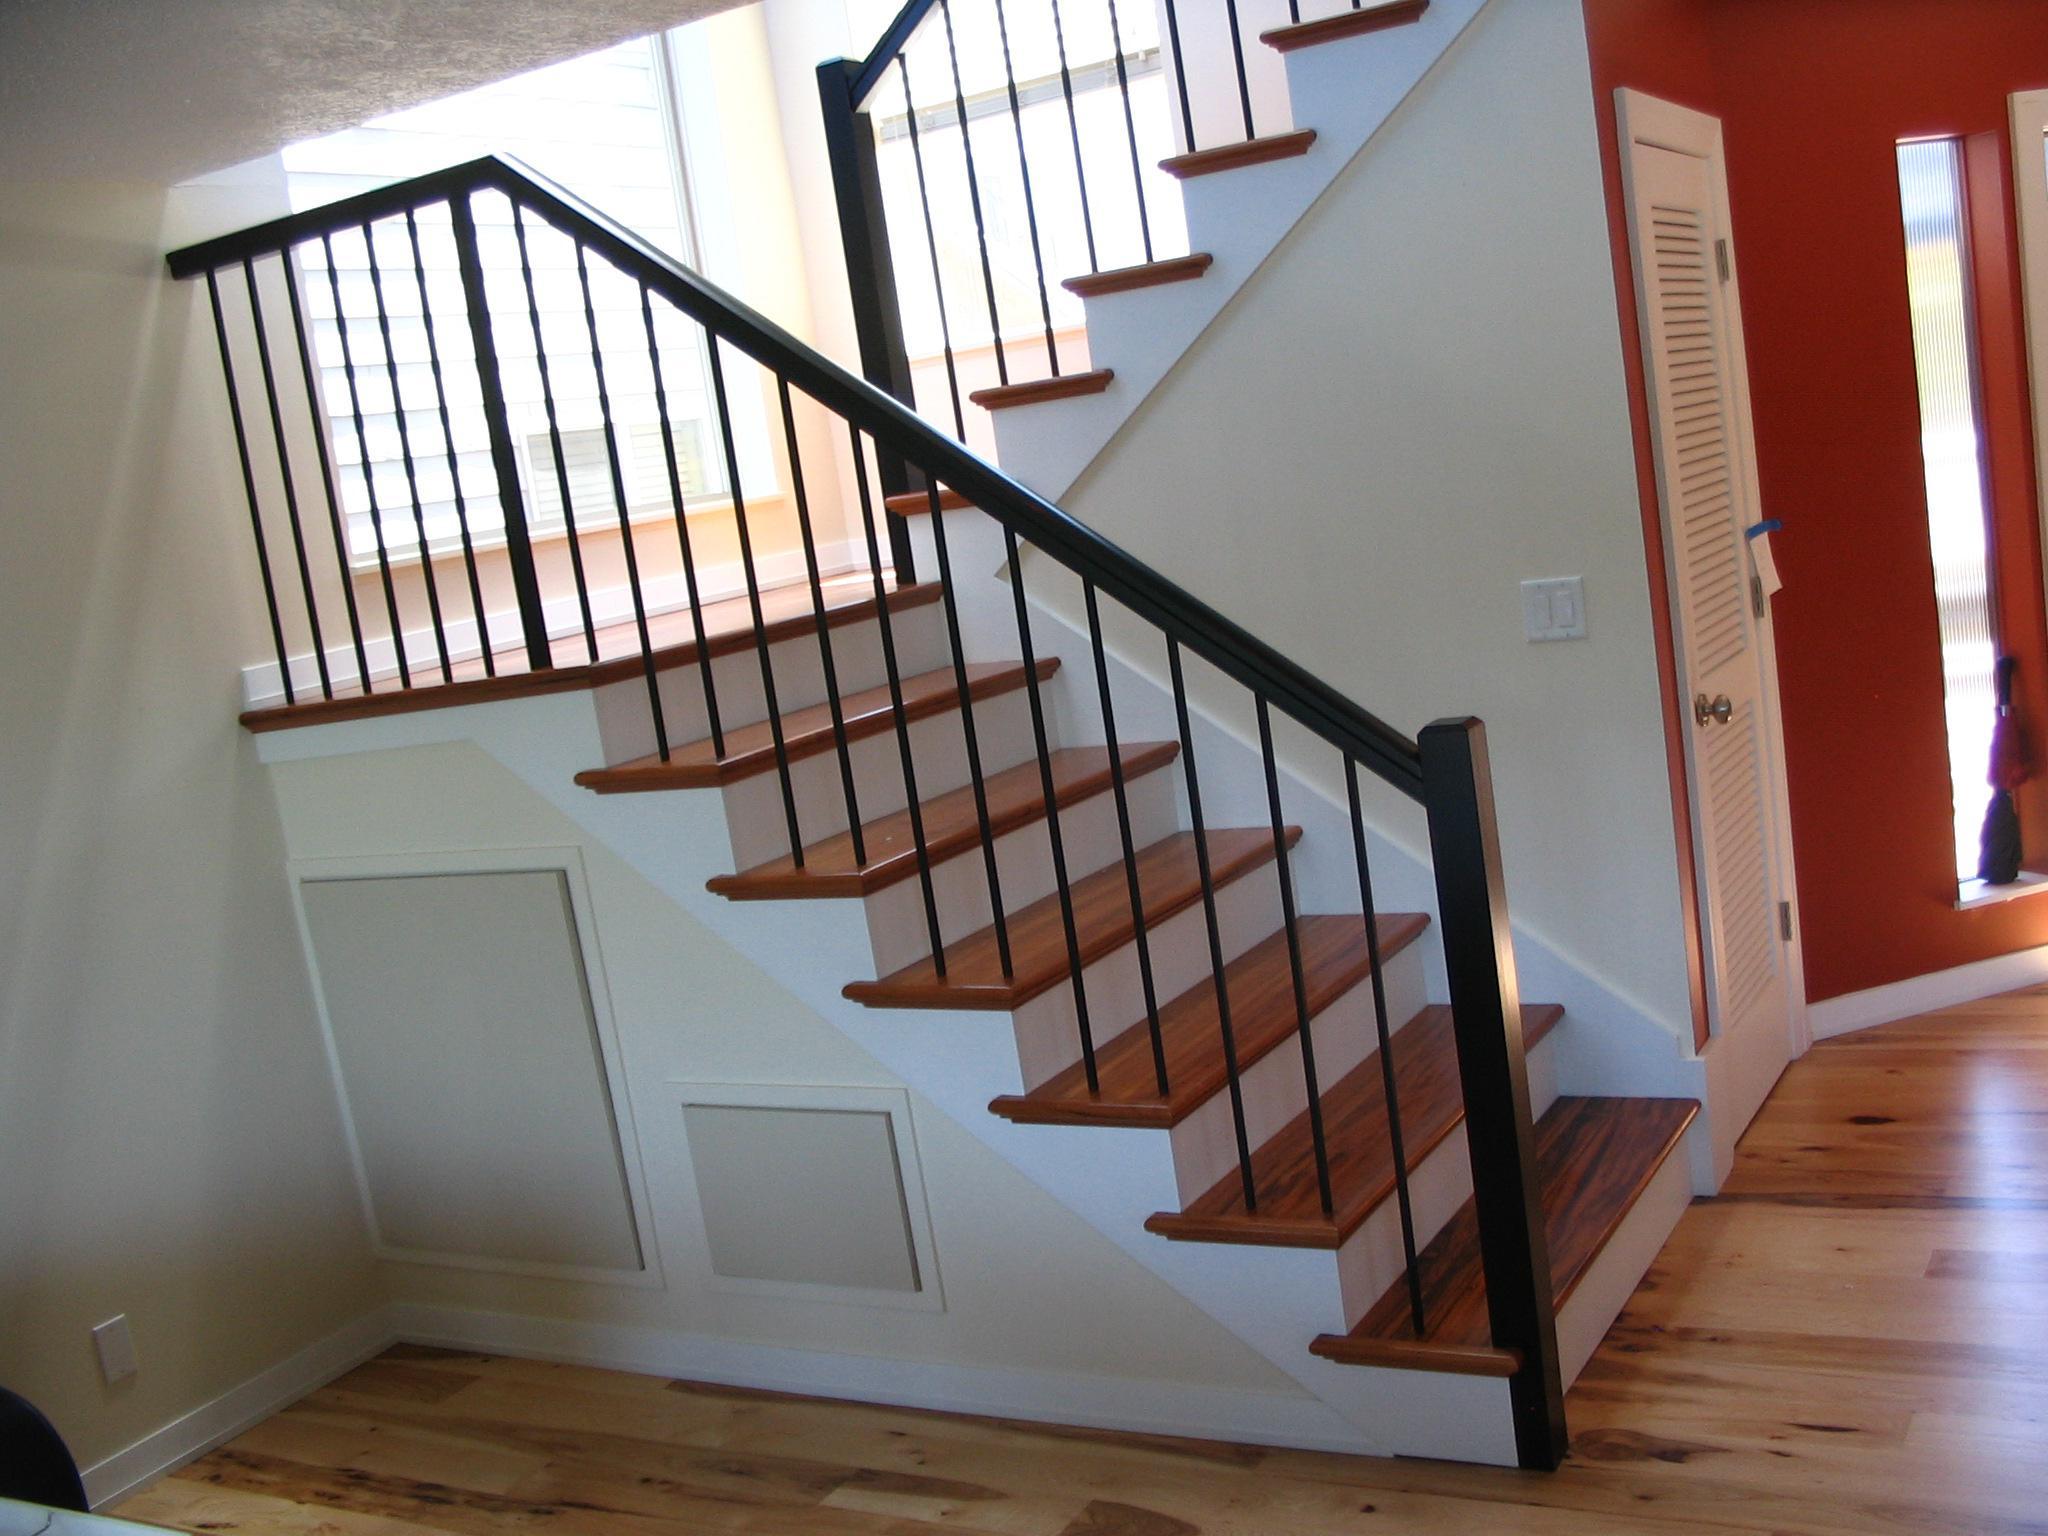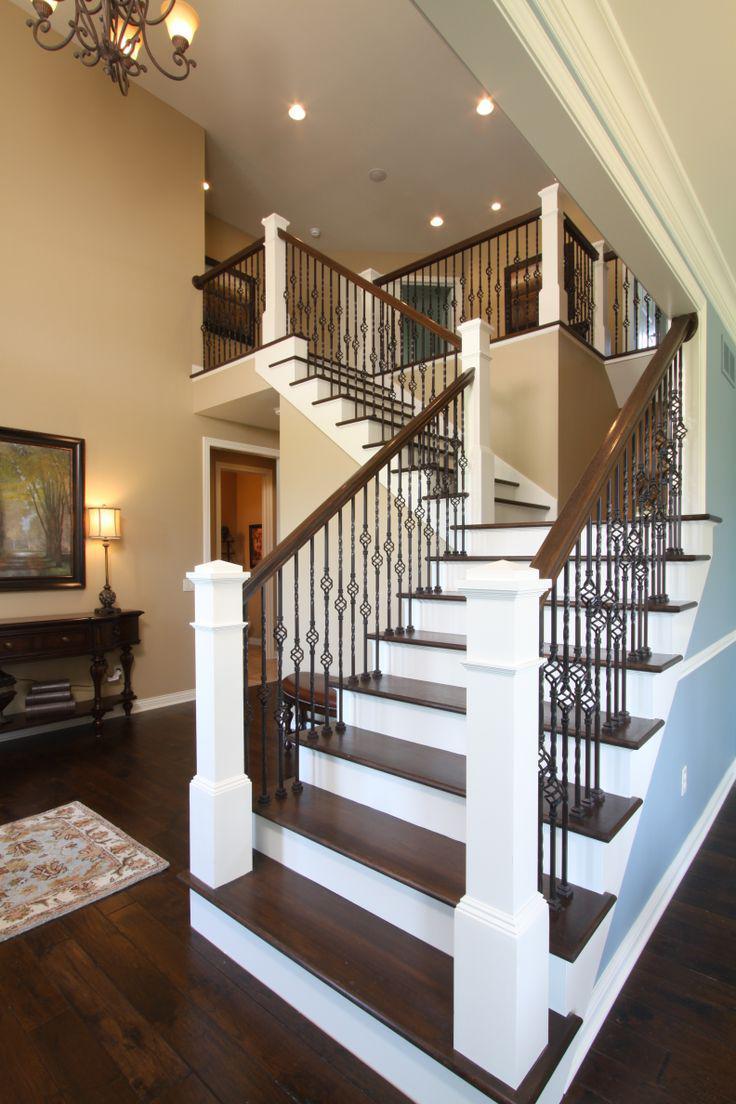The first image is the image on the left, the second image is the image on the right. Given the left and right images, does the statement "Two staircases and bannisters curve as they go downstairs." hold true? Answer yes or no. No. The first image is the image on the left, the second image is the image on the right. Analyze the images presented: Is the assertion "there is a wood rail staircase with black iron rods and carpeted stairs" valid? Answer yes or no. No. 